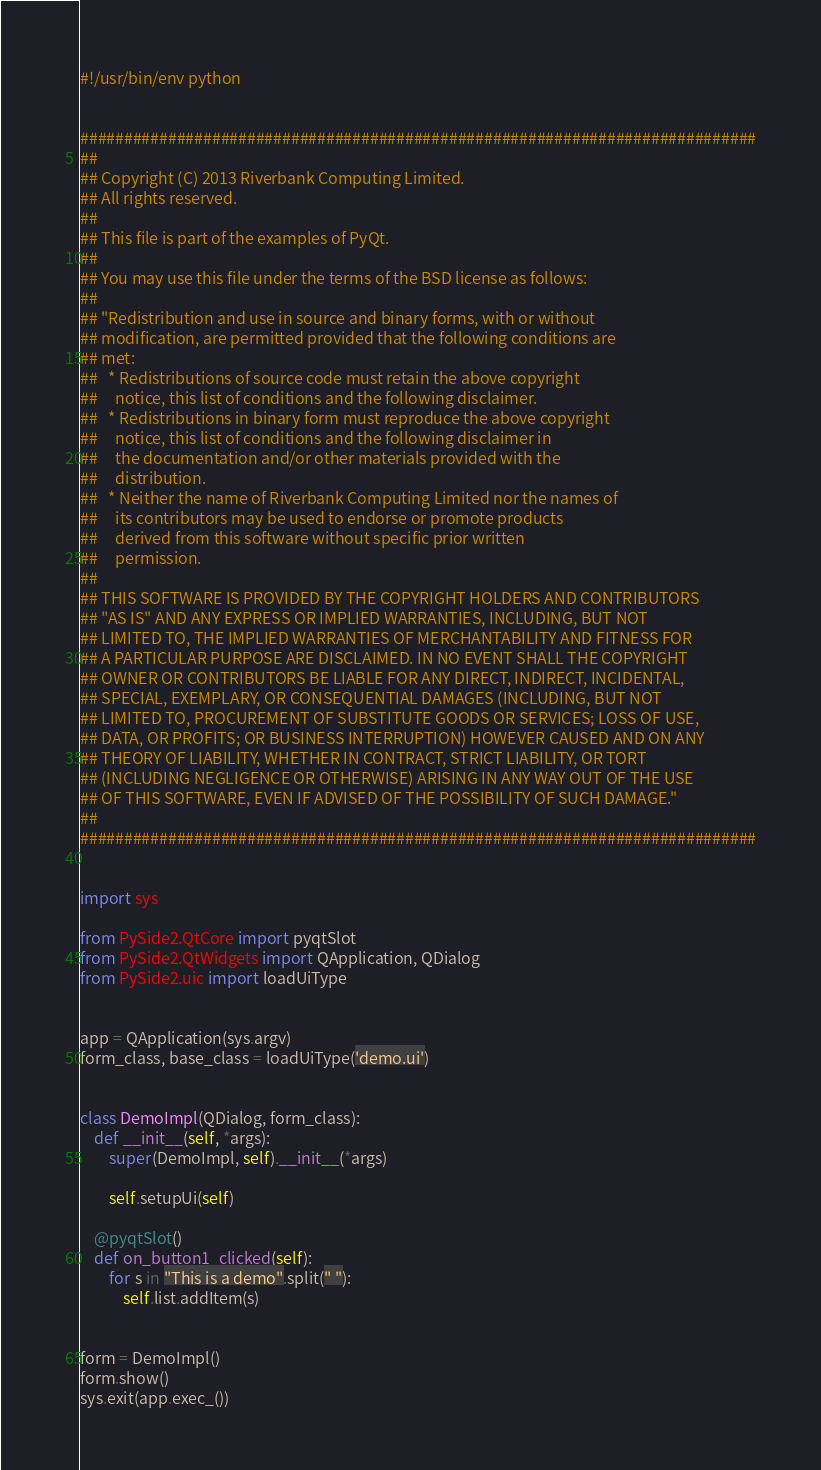Convert code to text. <code><loc_0><loc_0><loc_500><loc_500><_Python_>#!/usr/bin/env python


#############################################################################
##
## Copyright (C) 2013 Riverbank Computing Limited.
## All rights reserved.
##
## This file is part of the examples of PyQt.
##
## You may use this file under the terms of the BSD license as follows:
##
## "Redistribution and use in source and binary forms, with or without
## modification, are permitted provided that the following conditions are
## met:
##   * Redistributions of source code must retain the above copyright
##     notice, this list of conditions and the following disclaimer.
##   * Redistributions in binary form must reproduce the above copyright
##     notice, this list of conditions and the following disclaimer in
##     the documentation and/or other materials provided with the
##     distribution.
##   * Neither the name of Riverbank Computing Limited nor the names of
##     its contributors may be used to endorse or promote products
##     derived from this software without specific prior written
##     permission.
##
## THIS SOFTWARE IS PROVIDED BY THE COPYRIGHT HOLDERS AND CONTRIBUTORS
## "AS IS" AND ANY EXPRESS OR IMPLIED WARRANTIES, INCLUDING, BUT NOT
## LIMITED TO, THE IMPLIED WARRANTIES OF MERCHANTABILITY AND FITNESS FOR
## A PARTICULAR PURPOSE ARE DISCLAIMED. IN NO EVENT SHALL THE COPYRIGHT
## OWNER OR CONTRIBUTORS BE LIABLE FOR ANY DIRECT, INDIRECT, INCIDENTAL,
## SPECIAL, EXEMPLARY, OR CONSEQUENTIAL DAMAGES (INCLUDING, BUT NOT
## LIMITED TO, PROCUREMENT OF SUBSTITUTE GOODS OR SERVICES; LOSS OF USE,
## DATA, OR PROFITS; OR BUSINESS INTERRUPTION) HOWEVER CAUSED AND ON ANY
## THEORY OF LIABILITY, WHETHER IN CONTRACT, STRICT LIABILITY, OR TORT
## (INCLUDING NEGLIGENCE OR OTHERWISE) ARISING IN ANY WAY OUT OF THE USE
## OF THIS SOFTWARE, EVEN IF ADVISED OF THE POSSIBILITY OF SUCH DAMAGE."
##
#############################################################################


import sys

from PySide2.QtCore import pyqtSlot
from PySide2.QtWidgets import QApplication, QDialog
from PySide2.uic import loadUiType


app = QApplication(sys.argv)
form_class, base_class = loadUiType('demo.ui')


class DemoImpl(QDialog, form_class):
    def __init__(self, *args):
        super(DemoImpl, self).__init__(*args)

        self.setupUi(self)
    
    @pyqtSlot()
    def on_button1_clicked(self):
        for s in "This is a demo".split(" "):
            self.list.addItem(s)


form = DemoImpl()
form.show()
sys.exit(app.exec_())
</code> 